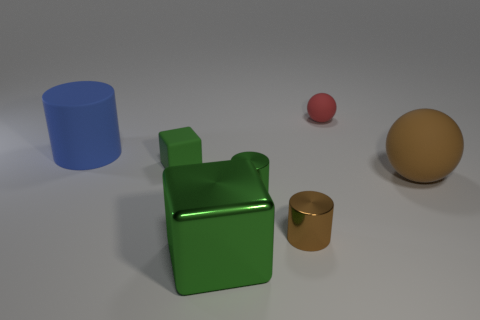Subtract all small cylinders. How many cylinders are left? 1 Add 3 large green shiny objects. How many objects exist? 10 Subtract 3 cylinders. How many cylinders are left? 0 Subtract all blocks. How many objects are left? 5 Add 4 big rubber cylinders. How many big rubber cylinders are left? 5 Add 2 green spheres. How many green spheres exist? 2 Subtract all blue cylinders. How many cylinders are left? 2 Subtract 1 brown cylinders. How many objects are left? 6 Subtract all brown cylinders. Subtract all green spheres. How many cylinders are left? 2 Subtract all brown cylinders. Subtract all shiny balls. How many objects are left? 6 